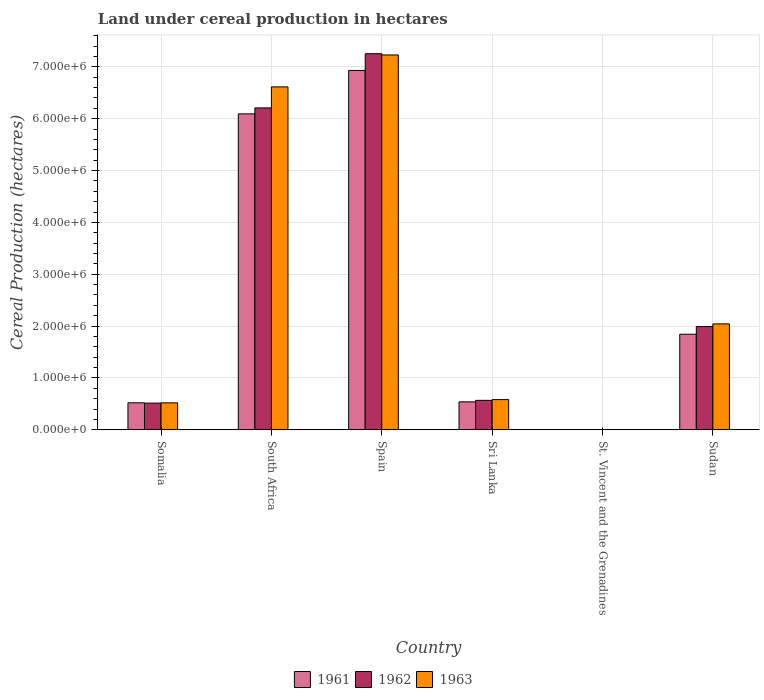How many groups of bars are there?
Your answer should be compact. 6. Are the number of bars per tick equal to the number of legend labels?
Provide a short and direct response. Yes. What is the label of the 4th group of bars from the left?
Ensure brevity in your answer.  Sri Lanka. What is the land under cereal production in 1962 in Somalia?
Ensure brevity in your answer.  5.15e+05. Across all countries, what is the maximum land under cereal production in 1963?
Ensure brevity in your answer.  7.23e+06. Across all countries, what is the minimum land under cereal production in 1963?
Your answer should be compact. 100. In which country was the land under cereal production in 1962 maximum?
Keep it short and to the point. Spain. In which country was the land under cereal production in 1962 minimum?
Make the answer very short. St. Vincent and the Grenadines. What is the total land under cereal production in 1962 in the graph?
Offer a terse response. 1.65e+07. What is the difference between the land under cereal production in 1961 in Somalia and that in Spain?
Offer a very short reply. -6.41e+06. What is the difference between the land under cereal production in 1961 in Sri Lanka and the land under cereal production in 1962 in Sudan?
Offer a terse response. -1.45e+06. What is the average land under cereal production in 1963 per country?
Your answer should be very brief. 2.83e+06. What is the difference between the land under cereal production of/in 1962 and land under cereal production of/in 1961 in Spain?
Your answer should be compact. 3.23e+05. In how many countries, is the land under cereal production in 1962 greater than 1400000 hectares?
Your answer should be very brief. 3. What is the ratio of the land under cereal production in 1961 in Spain to that in Sri Lanka?
Give a very brief answer. 12.85. Is the difference between the land under cereal production in 1962 in Somalia and Sudan greater than the difference between the land under cereal production in 1961 in Somalia and Sudan?
Keep it short and to the point. No. What is the difference between the highest and the second highest land under cereal production in 1961?
Provide a short and direct response. -8.37e+05. What is the difference between the highest and the lowest land under cereal production in 1962?
Provide a short and direct response. 7.25e+06. In how many countries, is the land under cereal production in 1961 greater than the average land under cereal production in 1961 taken over all countries?
Provide a succinct answer. 2. Is the sum of the land under cereal production in 1961 in Somalia and Sri Lanka greater than the maximum land under cereal production in 1963 across all countries?
Ensure brevity in your answer.  No. How many bars are there?
Your answer should be compact. 18. Are all the bars in the graph horizontal?
Your response must be concise. No. What is the difference between two consecutive major ticks on the Y-axis?
Your response must be concise. 1.00e+06. Does the graph contain grids?
Give a very brief answer. Yes. How many legend labels are there?
Your response must be concise. 3. How are the legend labels stacked?
Make the answer very short. Horizontal. What is the title of the graph?
Keep it short and to the point. Land under cereal production in hectares. Does "1988" appear as one of the legend labels in the graph?
Make the answer very short. No. What is the label or title of the X-axis?
Provide a short and direct response. Country. What is the label or title of the Y-axis?
Your answer should be very brief. Cereal Production (hectares). What is the Cereal Production (hectares) of 1961 in Somalia?
Keep it short and to the point. 5.21e+05. What is the Cereal Production (hectares) in 1962 in Somalia?
Your response must be concise. 5.15e+05. What is the Cereal Production (hectares) of 1963 in Somalia?
Give a very brief answer. 5.20e+05. What is the Cereal Production (hectares) in 1961 in South Africa?
Your response must be concise. 6.09e+06. What is the Cereal Production (hectares) of 1962 in South Africa?
Provide a succinct answer. 6.21e+06. What is the Cereal Production (hectares) of 1963 in South Africa?
Keep it short and to the point. 6.61e+06. What is the Cereal Production (hectares) in 1961 in Spain?
Provide a short and direct response. 6.93e+06. What is the Cereal Production (hectares) of 1962 in Spain?
Offer a terse response. 7.25e+06. What is the Cereal Production (hectares) in 1963 in Spain?
Provide a short and direct response. 7.23e+06. What is the Cereal Production (hectares) in 1961 in Sri Lanka?
Give a very brief answer. 5.39e+05. What is the Cereal Production (hectares) of 1962 in Sri Lanka?
Offer a terse response. 5.68e+05. What is the Cereal Production (hectares) of 1963 in Sri Lanka?
Your response must be concise. 5.82e+05. What is the Cereal Production (hectares) in 1962 in St. Vincent and the Grenadines?
Your response must be concise. 100. What is the Cereal Production (hectares) of 1963 in St. Vincent and the Grenadines?
Make the answer very short. 100. What is the Cereal Production (hectares) of 1961 in Sudan?
Provide a succinct answer. 1.84e+06. What is the Cereal Production (hectares) of 1962 in Sudan?
Keep it short and to the point. 1.99e+06. What is the Cereal Production (hectares) in 1963 in Sudan?
Offer a very short reply. 2.04e+06. Across all countries, what is the maximum Cereal Production (hectares) in 1961?
Make the answer very short. 6.93e+06. Across all countries, what is the maximum Cereal Production (hectares) of 1962?
Your response must be concise. 7.25e+06. Across all countries, what is the maximum Cereal Production (hectares) of 1963?
Ensure brevity in your answer.  7.23e+06. Across all countries, what is the minimum Cereal Production (hectares) of 1961?
Ensure brevity in your answer.  100. Across all countries, what is the minimum Cereal Production (hectares) in 1963?
Keep it short and to the point. 100. What is the total Cereal Production (hectares) in 1961 in the graph?
Keep it short and to the point. 1.59e+07. What is the total Cereal Production (hectares) in 1962 in the graph?
Provide a short and direct response. 1.65e+07. What is the total Cereal Production (hectares) of 1963 in the graph?
Your response must be concise. 1.70e+07. What is the difference between the Cereal Production (hectares) in 1961 in Somalia and that in South Africa?
Your answer should be very brief. -5.57e+06. What is the difference between the Cereal Production (hectares) in 1962 in Somalia and that in South Africa?
Give a very brief answer. -5.69e+06. What is the difference between the Cereal Production (hectares) in 1963 in Somalia and that in South Africa?
Your answer should be very brief. -6.09e+06. What is the difference between the Cereal Production (hectares) in 1961 in Somalia and that in Spain?
Offer a terse response. -6.41e+06. What is the difference between the Cereal Production (hectares) of 1962 in Somalia and that in Spain?
Your answer should be compact. -6.74e+06. What is the difference between the Cereal Production (hectares) of 1963 in Somalia and that in Spain?
Your response must be concise. -6.71e+06. What is the difference between the Cereal Production (hectares) in 1961 in Somalia and that in Sri Lanka?
Your answer should be compact. -1.82e+04. What is the difference between the Cereal Production (hectares) of 1962 in Somalia and that in Sri Lanka?
Your answer should be compact. -5.31e+04. What is the difference between the Cereal Production (hectares) of 1963 in Somalia and that in Sri Lanka?
Offer a terse response. -6.25e+04. What is the difference between the Cereal Production (hectares) in 1961 in Somalia and that in St. Vincent and the Grenadines?
Make the answer very short. 5.21e+05. What is the difference between the Cereal Production (hectares) of 1962 in Somalia and that in St. Vincent and the Grenadines?
Make the answer very short. 5.15e+05. What is the difference between the Cereal Production (hectares) of 1963 in Somalia and that in St. Vincent and the Grenadines?
Your answer should be compact. 5.20e+05. What is the difference between the Cereal Production (hectares) in 1961 in Somalia and that in Sudan?
Offer a terse response. -1.32e+06. What is the difference between the Cereal Production (hectares) of 1962 in Somalia and that in Sudan?
Ensure brevity in your answer.  -1.48e+06. What is the difference between the Cereal Production (hectares) of 1963 in Somalia and that in Sudan?
Offer a terse response. -1.52e+06. What is the difference between the Cereal Production (hectares) in 1961 in South Africa and that in Spain?
Your response must be concise. -8.37e+05. What is the difference between the Cereal Production (hectares) of 1962 in South Africa and that in Spain?
Make the answer very short. -1.05e+06. What is the difference between the Cereal Production (hectares) in 1963 in South Africa and that in Spain?
Give a very brief answer. -6.16e+05. What is the difference between the Cereal Production (hectares) in 1961 in South Africa and that in Sri Lanka?
Provide a short and direct response. 5.55e+06. What is the difference between the Cereal Production (hectares) of 1962 in South Africa and that in Sri Lanka?
Ensure brevity in your answer.  5.64e+06. What is the difference between the Cereal Production (hectares) in 1963 in South Africa and that in Sri Lanka?
Ensure brevity in your answer.  6.03e+06. What is the difference between the Cereal Production (hectares) of 1961 in South Africa and that in St. Vincent and the Grenadines?
Your response must be concise. 6.09e+06. What is the difference between the Cereal Production (hectares) of 1962 in South Africa and that in St. Vincent and the Grenadines?
Give a very brief answer. 6.21e+06. What is the difference between the Cereal Production (hectares) of 1963 in South Africa and that in St. Vincent and the Grenadines?
Keep it short and to the point. 6.61e+06. What is the difference between the Cereal Production (hectares) of 1961 in South Africa and that in Sudan?
Make the answer very short. 4.25e+06. What is the difference between the Cereal Production (hectares) in 1962 in South Africa and that in Sudan?
Offer a terse response. 4.22e+06. What is the difference between the Cereal Production (hectares) of 1963 in South Africa and that in Sudan?
Ensure brevity in your answer.  4.57e+06. What is the difference between the Cereal Production (hectares) in 1961 in Spain and that in Sri Lanka?
Offer a terse response. 6.39e+06. What is the difference between the Cereal Production (hectares) in 1962 in Spain and that in Sri Lanka?
Offer a very short reply. 6.68e+06. What is the difference between the Cereal Production (hectares) in 1963 in Spain and that in Sri Lanka?
Ensure brevity in your answer.  6.65e+06. What is the difference between the Cereal Production (hectares) of 1961 in Spain and that in St. Vincent and the Grenadines?
Your answer should be compact. 6.93e+06. What is the difference between the Cereal Production (hectares) in 1962 in Spain and that in St. Vincent and the Grenadines?
Your answer should be very brief. 7.25e+06. What is the difference between the Cereal Production (hectares) in 1963 in Spain and that in St. Vincent and the Grenadines?
Ensure brevity in your answer.  7.23e+06. What is the difference between the Cereal Production (hectares) in 1961 in Spain and that in Sudan?
Provide a succinct answer. 5.09e+06. What is the difference between the Cereal Production (hectares) in 1962 in Spain and that in Sudan?
Provide a short and direct response. 5.26e+06. What is the difference between the Cereal Production (hectares) in 1963 in Spain and that in Sudan?
Provide a succinct answer. 5.19e+06. What is the difference between the Cereal Production (hectares) of 1961 in Sri Lanka and that in St. Vincent and the Grenadines?
Make the answer very short. 5.39e+05. What is the difference between the Cereal Production (hectares) of 1962 in Sri Lanka and that in St. Vincent and the Grenadines?
Provide a short and direct response. 5.68e+05. What is the difference between the Cereal Production (hectares) of 1963 in Sri Lanka and that in St. Vincent and the Grenadines?
Ensure brevity in your answer.  5.82e+05. What is the difference between the Cereal Production (hectares) of 1961 in Sri Lanka and that in Sudan?
Your response must be concise. -1.30e+06. What is the difference between the Cereal Production (hectares) in 1962 in Sri Lanka and that in Sudan?
Give a very brief answer. -1.42e+06. What is the difference between the Cereal Production (hectares) in 1963 in Sri Lanka and that in Sudan?
Keep it short and to the point. -1.46e+06. What is the difference between the Cereal Production (hectares) in 1961 in St. Vincent and the Grenadines and that in Sudan?
Give a very brief answer. -1.84e+06. What is the difference between the Cereal Production (hectares) of 1962 in St. Vincent and the Grenadines and that in Sudan?
Make the answer very short. -1.99e+06. What is the difference between the Cereal Production (hectares) of 1963 in St. Vincent and the Grenadines and that in Sudan?
Provide a short and direct response. -2.04e+06. What is the difference between the Cereal Production (hectares) of 1961 in Somalia and the Cereal Production (hectares) of 1962 in South Africa?
Your answer should be very brief. -5.69e+06. What is the difference between the Cereal Production (hectares) of 1961 in Somalia and the Cereal Production (hectares) of 1963 in South Africa?
Your answer should be compact. -6.09e+06. What is the difference between the Cereal Production (hectares) of 1962 in Somalia and the Cereal Production (hectares) of 1963 in South Africa?
Ensure brevity in your answer.  -6.10e+06. What is the difference between the Cereal Production (hectares) of 1961 in Somalia and the Cereal Production (hectares) of 1962 in Spain?
Your answer should be very brief. -6.73e+06. What is the difference between the Cereal Production (hectares) in 1961 in Somalia and the Cereal Production (hectares) in 1963 in Spain?
Give a very brief answer. -6.71e+06. What is the difference between the Cereal Production (hectares) of 1962 in Somalia and the Cereal Production (hectares) of 1963 in Spain?
Ensure brevity in your answer.  -6.71e+06. What is the difference between the Cereal Production (hectares) of 1961 in Somalia and the Cereal Production (hectares) of 1962 in Sri Lanka?
Offer a terse response. -4.71e+04. What is the difference between the Cereal Production (hectares) of 1961 in Somalia and the Cereal Production (hectares) of 1963 in Sri Lanka?
Ensure brevity in your answer.  -6.15e+04. What is the difference between the Cereal Production (hectares) of 1962 in Somalia and the Cereal Production (hectares) of 1963 in Sri Lanka?
Make the answer very short. -6.75e+04. What is the difference between the Cereal Production (hectares) in 1961 in Somalia and the Cereal Production (hectares) in 1962 in St. Vincent and the Grenadines?
Make the answer very short. 5.21e+05. What is the difference between the Cereal Production (hectares) in 1961 in Somalia and the Cereal Production (hectares) in 1963 in St. Vincent and the Grenadines?
Provide a short and direct response. 5.21e+05. What is the difference between the Cereal Production (hectares) of 1962 in Somalia and the Cereal Production (hectares) of 1963 in St. Vincent and the Grenadines?
Offer a terse response. 5.15e+05. What is the difference between the Cereal Production (hectares) of 1961 in Somalia and the Cereal Production (hectares) of 1962 in Sudan?
Provide a short and direct response. -1.47e+06. What is the difference between the Cereal Production (hectares) in 1961 in Somalia and the Cereal Production (hectares) in 1963 in Sudan?
Your answer should be very brief. -1.52e+06. What is the difference between the Cereal Production (hectares) of 1962 in Somalia and the Cereal Production (hectares) of 1963 in Sudan?
Give a very brief answer. -1.53e+06. What is the difference between the Cereal Production (hectares) in 1961 in South Africa and the Cereal Production (hectares) in 1962 in Spain?
Ensure brevity in your answer.  -1.16e+06. What is the difference between the Cereal Production (hectares) of 1961 in South Africa and the Cereal Production (hectares) of 1963 in Spain?
Ensure brevity in your answer.  -1.14e+06. What is the difference between the Cereal Production (hectares) of 1962 in South Africa and the Cereal Production (hectares) of 1963 in Spain?
Offer a very short reply. -1.02e+06. What is the difference between the Cereal Production (hectares) in 1961 in South Africa and the Cereal Production (hectares) in 1962 in Sri Lanka?
Ensure brevity in your answer.  5.52e+06. What is the difference between the Cereal Production (hectares) of 1961 in South Africa and the Cereal Production (hectares) of 1963 in Sri Lanka?
Provide a short and direct response. 5.51e+06. What is the difference between the Cereal Production (hectares) in 1962 in South Africa and the Cereal Production (hectares) in 1963 in Sri Lanka?
Make the answer very short. 5.63e+06. What is the difference between the Cereal Production (hectares) of 1961 in South Africa and the Cereal Production (hectares) of 1962 in St. Vincent and the Grenadines?
Your response must be concise. 6.09e+06. What is the difference between the Cereal Production (hectares) of 1961 in South Africa and the Cereal Production (hectares) of 1963 in St. Vincent and the Grenadines?
Give a very brief answer. 6.09e+06. What is the difference between the Cereal Production (hectares) in 1962 in South Africa and the Cereal Production (hectares) in 1963 in St. Vincent and the Grenadines?
Make the answer very short. 6.21e+06. What is the difference between the Cereal Production (hectares) of 1961 in South Africa and the Cereal Production (hectares) of 1962 in Sudan?
Ensure brevity in your answer.  4.10e+06. What is the difference between the Cereal Production (hectares) of 1961 in South Africa and the Cereal Production (hectares) of 1963 in Sudan?
Ensure brevity in your answer.  4.05e+06. What is the difference between the Cereal Production (hectares) of 1962 in South Africa and the Cereal Production (hectares) of 1963 in Sudan?
Give a very brief answer. 4.16e+06. What is the difference between the Cereal Production (hectares) in 1961 in Spain and the Cereal Production (hectares) in 1962 in Sri Lanka?
Offer a very short reply. 6.36e+06. What is the difference between the Cereal Production (hectares) in 1961 in Spain and the Cereal Production (hectares) in 1963 in Sri Lanka?
Offer a very short reply. 6.35e+06. What is the difference between the Cereal Production (hectares) of 1962 in Spain and the Cereal Production (hectares) of 1963 in Sri Lanka?
Ensure brevity in your answer.  6.67e+06. What is the difference between the Cereal Production (hectares) of 1961 in Spain and the Cereal Production (hectares) of 1962 in St. Vincent and the Grenadines?
Your answer should be compact. 6.93e+06. What is the difference between the Cereal Production (hectares) of 1961 in Spain and the Cereal Production (hectares) of 1963 in St. Vincent and the Grenadines?
Your answer should be very brief. 6.93e+06. What is the difference between the Cereal Production (hectares) of 1962 in Spain and the Cereal Production (hectares) of 1963 in St. Vincent and the Grenadines?
Offer a very short reply. 7.25e+06. What is the difference between the Cereal Production (hectares) in 1961 in Spain and the Cereal Production (hectares) in 1962 in Sudan?
Give a very brief answer. 4.94e+06. What is the difference between the Cereal Production (hectares) in 1961 in Spain and the Cereal Production (hectares) in 1963 in Sudan?
Offer a terse response. 4.89e+06. What is the difference between the Cereal Production (hectares) of 1962 in Spain and the Cereal Production (hectares) of 1963 in Sudan?
Give a very brief answer. 5.21e+06. What is the difference between the Cereal Production (hectares) of 1961 in Sri Lanka and the Cereal Production (hectares) of 1962 in St. Vincent and the Grenadines?
Make the answer very short. 5.39e+05. What is the difference between the Cereal Production (hectares) of 1961 in Sri Lanka and the Cereal Production (hectares) of 1963 in St. Vincent and the Grenadines?
Offer a very short reply. 5.39e+05. What is the difference between the Cereal Production (hectares) in 1962 in Sri Lanka and the Cereal Production (hectares) in 1963 in St. Vincent and the Grenadines?
Provide a short and direct response. 5.68e+05. What is the difference between the Cereal Production (hectares) in 1961 in Sri Lanka and the Cereal Production (hectares) in 1962 in Sudan?
Offer a terse response. -1.45e+06. What is the difference between the Cereal Production (hectares) in 1961 in Sri Lanka and the Cereal Production (hectares) in 1963 in Sudan?
Keep it short and to the point. -1.50e+06. What is the difference between the Cereal Production (hectares) in 1962 in Sri Lanka and the Cereal Production (hectares) in 1963 in Sudan?
Your answer should be compact. -1.47e+06. What is the difference between the Cereal Production (hectares) in 1961 in St. Vincent and the Grenadines and the Cereal Production (hectares) in 1962 in Sudan?
Give a very brief answer. -1.99e+06. What is the difference between the Cereal Production (hectares) in 1961 in St. Vincent and the Grenadines and the Cereal Production (hectares) in 1963 in Sudan?
Ensure brevity in your answer.  -2.04e+06. What is the difference between the Cereal Production (hectares) of 1962 in St. Vincent and the Grenadines and the Cereal Production (hectares) of 1963 in Sudan?
Make the answer very short. -2.04e+06. What is the average Cereal Production (hectares) in 1961 per country?
Your response must be concise. 2.65e+06. What is the average Cereal Production (hectares) of 1962 per country?
Your response must be concise. 2.76e+06. What is the average Cereal Production (hectares) in 1963 per country?
Offer a very short reply. 2.83e+06. What is the difference between the Cereal Production (hectares) in 1961 and Cereal Production (hectares) in 1962 in Somalia?
Ensure brevity in your answer.  6000. What is the difference between the Cereal Production (hectares) in 1961 and Cereal Production (hectares) in 1963 in Somalia?
Make the answer very short. 1000. What is the difference between the Cereal Production (hectares) of 1962 and Cereal Production (hectares) of 1963 in Somalia?
Provide a short and direct response. -5000. What is the difference between the Cereal Production (hectares) in 1961 and Cereal Production (hectares) in 1962 in South Africa?
Keep it short and to the point. -1.15e+05. What is the difference between the Cereal Production (hectares) of 1961 and Cereal Production (hectares) of 1963 in South Africa?
Provide a short and direct response. -5.20e+05. What is the difference between the Cereal Production (hectares) in 1962 and Cereal Production (hectares) in 1963 in South Africa?
Ensure brevity in your answer.  -4.05e+05. What is the difference between the Cereal Production (hectares) in 1961 and Cereal Production (hectares) in 1962 in Spain?
Your answer should be very brief. -3.23e+05. What is the difference between the Cereal Production (hectares) in 1961 and Cereal Production (hectares) in 1963 in Spain?
Your answer should be very brief. -2.99e+05. What is the difference between the Cereal Production (hectares) of 1962 and Cereal Production (hectares) of 1963 in Spain?
Provide a succinct answer. 2.46e+04. What is the difference between the Cereal Production (hectares) of 1961 and Cereal Production (hectares) of 1962 in Sri Lanka?
Your answer should be very brief. -2.89e+04. What is the difference between the Cereal Production (hectares) in 1961 and Cereal Production (hectares) in 1963 in Sri Lanka?
Offer a terse response. -4.33e+04. What is the difference between the Cereal Production (hectares) in 1962 and Cereal Production (hectares) in 1963 in Sri Lanka?
Your response must be concise. -1.44e+04. What is the difference between the Cereal Production (hectares) in 1961 and Cereal Production (hectares) in 1962 in St. Vincent and the Grenadines?
Offer a very short reply. 0. What is the difference between the Cereal Production (hectares) in 1961 and Cereal Production (hectares) in 1963 in St. Vincent and the Grenadines?
Provide a short and direct response. 0. What is the difference between the Cereal Production (hectares) in 1961 and Cereal Production (hectares) in 1962 in Sudan?
Offer a very short reply. -1.48e+05. What is the difference between the Cereal Production (hectares) of 1961 and Cereal Production (hectares) of 1963 in Sudan?
Offer a terse response. -2.00e+05. What is the difference between the Cereal Production (hectares) in 1962 and Cereal Production (hectares) in 1963 in Sudan?
Give a very brief answer. -5.14e+04. What is the ratio of the Cereal Production (hectares) in 1961 in Somalia to that in South Africa?
Offer a terse response. 0.09. What is the ratio of the Cereal Production (hectares) of 1962 in Somalia to that in South Africa?
Your answer should be very brief. 0.08. What is the ratio of the Cereal Production (hectares) of 1963 in Somalia to that in South Africa?
Make the answer very short. 0.08. What is the ratio of the Cereal Production (hectares) of 1961 in Somalia to that in Spain?
Keep it short and to the point. 0.08. What is the ratio of the Cereal Production (hectares) of 1962 in Somalia to that in Spain?
Ensure brevity in your answer.  0.07. What is the ratio of the Cereal Production (hectares) of 1963 in Somalia to that in Spain?
Make the answer very short. 0.07. What is the ratio of the Cereal Production (hectares) in 1961 in Somalia to that in Sri Lanka?
Your answer should be compact. 0.97. What is the ratio of the Cereal Production (hectares) in 1962 in Somalia to that in Sri Lanka?
Provide a short and direct response. 0.91. What is the ratio of the Cereal Production (hectares) of 1963 in Somalia to that in Sri Lanka?
Provide a succinct answer. 0.89. What is the ratio of the Cereal Production (hectares) in 1961 in Somalia to that in St. Vincent and the Grenadines?
Your answer should be very brief. 5210. What is the ratio of the Cereal Production (hectares) of 1962 in Somalia to that in St. Vincent and the Grenadines?
Your answer should be compact. 5150. What is the ratio of the Cereal Production (hectares) in 1963 in Somalia to that in St. Vincent and the Grenadines?
Offer a terse response. 5200. What is the ratio of the Cereal Production (hectares) in 1961 in Somalia to that in Sudan?
Offer a very short reply. 0.28. What is the ratio of the Cereal Production (hectares) in 1962 in Somalia to that in Sudan?
Your answer should be very brief. 0.26. What is the ratio of the Cereal Production (hectares) in 1963 in Somalia to that in Sudan?
Offer a very short reply. 0.25. What is the ratio of the Cereal Production (hectares) of 1961 in South Africa to that in Spain?
Offer a terse response. 0.88. What is the ratio of the Cereal Production (hectares) of 1962 in South Africa to that in Spain?
Keep it short and to the point. 0.86. What is the ratio of the Cereal Production (hectares) in 1963 in South Africa to that in Spain?
Offer a terse response. 0.91. What is the ratio of the Cereal Production (hectares) of 1961 in South Africa to that in Sri Lanka?
Your answer should be compact. 11.3. What is the ratio of the Cereal Production (hectares) of 1962 in South Africa to that in Sri Lanka?
Your response must be concise. 10.93. What is the ratio of the Cereal Production (hectares) in 1963 in South Africa to that in Sri Lanka?
Provide a succinct answer. 11.35. What is the ratio of the Cereal Production (hectares) of 1961 in South Africa to that in St. Vincent and the Grenadines?
Give a very brief answer. 6.09e+04. What is the ratio of the Cereal Production (hectares) in 1962 in South Africa to that in St. Vincent and the Grenadines?
Ensure brevity in your answer.  6.21e+04. What is the ratio of the Cereal Production (hectares) of 1963 in South Africa to that in St. Vincent and the Grenadines?
Make the answer very short. 6.61e+04. What is the ratio of the Cereal Production (hectares) in 1961 in South Africa to that in Sudan?
Provide a short and direct response. 3.31. What is the ratio of the Cereal Production (hectares) in 1962 in South Africa to that in Sudan?
Your answer should be very brief. 3.12. What is the ratio of the Cereal Production (hectares) in 1963 in South Africa to that in Sudan?
Your answer should be very brief. 3.24. What is the ratio of the Cereal Production (hectares) in 1961 in Spain to that in Sri Lanka?
Your response must be concise. 12.85. What is the ratio of the Cereal Production (hectares) in 1962 in Spain to that in Sri Lanka?
Your answer should be very brief. 12.77. What is the ratio of the Cereal Production (hectares) in 1963 in Spain to that in Sri Lanka?
Provide a short and direct response. 12.41. What is the ratio of the Cereal Production (hectares) in 1961 in Spain to that in St. Vincent and the Grenadines?
Offer a very short reply. 6.93e+04. What is the ratio of the Cereal Production (hectares) of 1962 in Spain to that in St. Vincent and the Grenadines?
Offer a terse response. 7.25e+04. What is the ratio of the Cereal Production (hectares) of 1963 in Spain to that in St. Vincent and the Grenadines?
Provide a short and direct response. 7.23e+04. What is the ratio of the Cereal Production (hectares) of 1961 in Spain to that in Sudan?
Your answer should be very brief. 3.76. What is the ratio of the Cereal Production (hectares) in 1962 in Spain to that in Sudan?
Offer a very short reply. 3.64. What is the ratio of the Cereal Production (hectares) of 1963 in Spain to that in Sudan?
Make the answer very short. 3.54. What is the ratio of the Cereal Production (hectares) in 1961 in Sri Lanka to that in St. Vincent and the Grenadines?
Make the answer very short. 5391.71. What is the ratio of the Cereal Production (hectares) in 1962 in Sri Lanka to that in St. Vincent and the Grenadines?
Provide a succinct answer. 5680.96. What is the ratio of the Cereal Production (hectares) of 1963 in Sri Lanka to that in St. Vincent and the Grenadines?
Give a very brief answer. 5824.57. What is the ratio of the Cereal Production (hectares) in 1961 in Sri Lanka to that in Sudan?
Your answer should be compact. 0.29. What is the ratio of the Cereal Production (hectares) of 1962 in Sri Lanka to that in Sudan?
Your response must be concise. 0.29. What is the ratio of the Cereal Production (hectares) in 1963 in Sri Lanka to that in Sudan?
Your answer should be compact. 0.29. What is the ratio of the Cereal Production (hectares) of 1961 in St. Vincent and the Grenadines to that in Sudan?
Provide a short and direct response. 0. What is the difference between the highest and the second highest Cereal Production (hectares) of 1961?
Offer a very short reply. 8.37e+05. What is the difference between the highest and the second highest Cereal Production (hectares) in 1962?
Provide a succinct answer. 1.05e+06. What is the difference between the highest and the second highest Cereal Production (hectares) in 1963?
Keep it short and to the point. 6.16e+05. What is the difference between the highest and the lowest Cereal Production (hectares) in 1961?
Keep it short and to the point. 6.93e+06. What is the difference between the highest and the lowest Cereal Production (hectares) in 1962?
Keep it short and to the point. 7.25e+06. What is the difference between the highest and the lowest Cereal Production (hectares) of 1963?
Keep it short and to the point. 7.23e+06. 